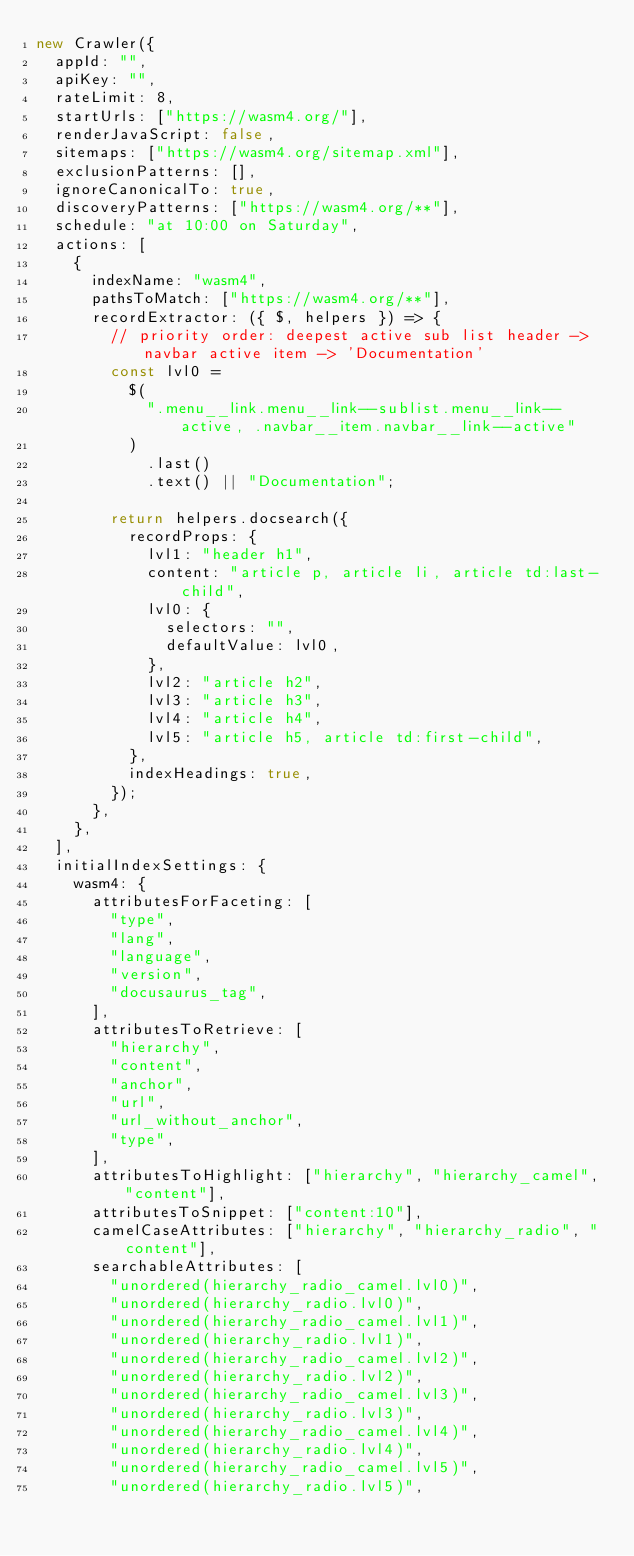Convert code to text. <code><loc_0><loc_0><loc_500><loc_500><_JavaScript_>new Crawler({
  appId: "",
  apiKey: "",
  rateLimit: 8,
  startUrls: ["https://wasm4.org/"],
  renderJavaScript: false,
  sitemaps: ["https://wasm4.org/sitemap.xml"],
  exclusionPatterns: [],
  ignoreCanonicalTo: true,
  discoveryPatterns: ["https://wasm4.org/**"],
  schedule: "at 10:00 on Saturday",
  actions: [
    {
      indexName: "wasm4",
      pathsToMatch: ["https://wasm4.org/**"],
      recordExtractor: ({ $, helpers }) => {
        // priority order: deepest active sub list header -> navbar active item -> 'Documentation'
        const lvl0 =
          $(
            ".menu__link.menu__link--sublist.menu__link--active, .navbar__item.navbar__link--active"
          )
            .last()
            .text() || "Documentation";

        return helpers.docsearch({
          recordProps: {
            lvl1: "header h1",
            content: "article p, article li, article td:last-child",
            lvl0: {
              selectors: "",
              defaultValue: lvl0,
            },
            lvl2: "article h2",
            lvl3: "article h3",
            lvl4: "article h4",
            lvl5: "article h5, article td:first-child",
          },
          indexHeadings: true,
        });
      },
    },
  ],
  initialIndexSettings: {
    wasm4: {
      attributesForFaceting: [
        "type",
        "lang",
        "language",
        "version",
        "docusaurus_tag",
      ],
      attributesToRetrieve: [
        "hierarchy",
        "content",
        "anchor",
        "url",
        "url_without_anchor",
        "type",
      ],
      attributesToHighlight: ["hierarchy", "hierarchy_camel", "content"],
      attributesToSnippet: ["content:10"],
      camelCaseAttributes: ["hierarchy", "hierarchy_radio", "content"],
      searchableAttributes: [
        "unordered(hierarchy_radio_camel.lvl0)",
        "unordered(hierarchy_radio.lvl0)",
        "unordered(hierarchy_radio_camel.lvl1)",
        "unordered(hierarchy_radio.lvl1)",
        "unordered(hierarchy_radio_camel.lvl2)",
        "unordered(hierarchy_radio.lvl2)",
        "unordered(hierarchy_radio_camel.lvl3)",
        "unordered(hierarchy_radio.lvl3)",
        "unordered(hierarchy_radio_camel.lvl4)",
        "unordered(hierarchy_radio.lvl4)",
        "unordered(hierarchy_radio_camel.lvl5)",
        "unordered(hierarchy_radio.lvl5)",</code> 